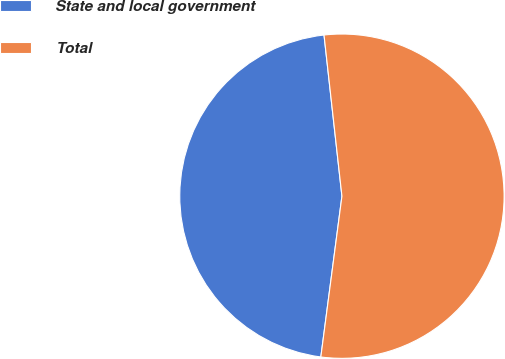Convert chart. <chart><loc_0><loc_0><loc_500><loc_500><pie_chart><fcel>State and local government<fcel>Total<nl><fcel>46.16%<fcel>53.84%<nl></chart> 